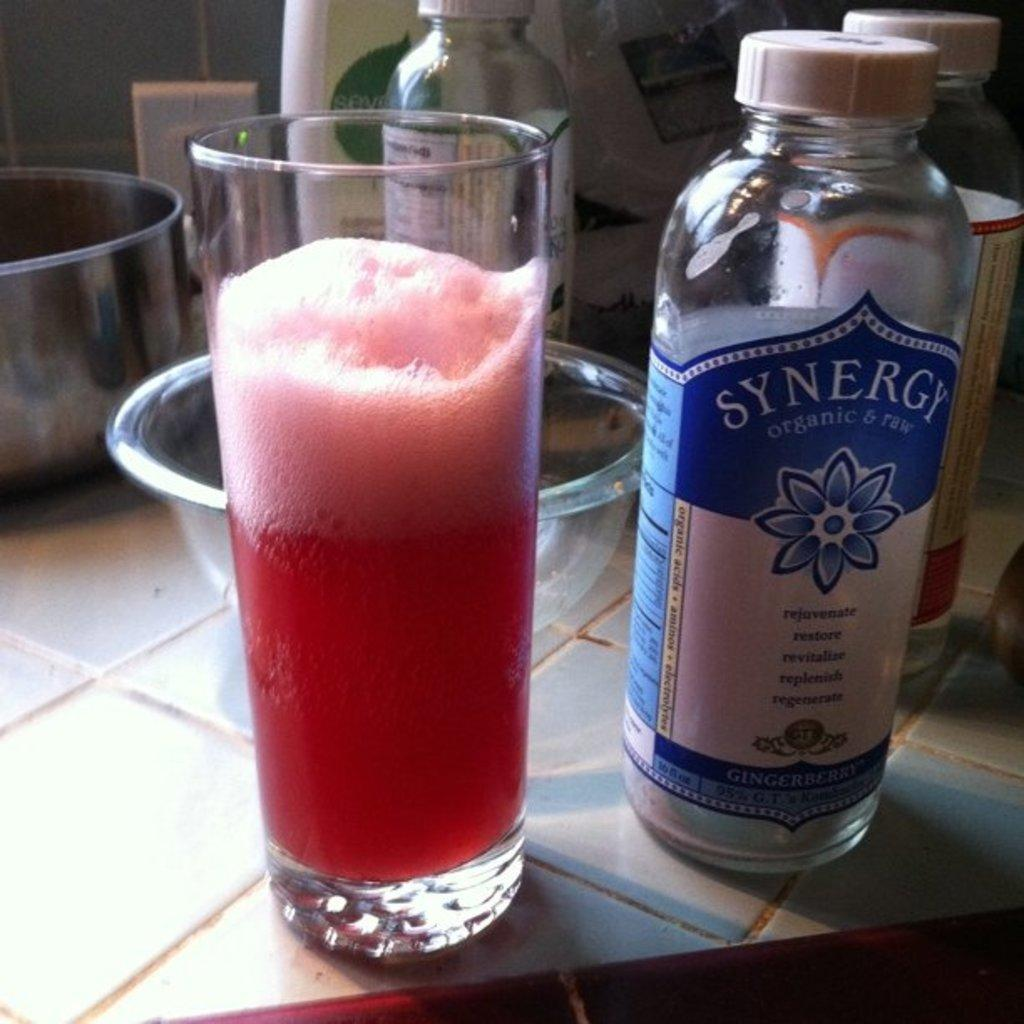<image>
Render a clear and concise summary of the photo. A glass next to a bottle of Synergy beverage 